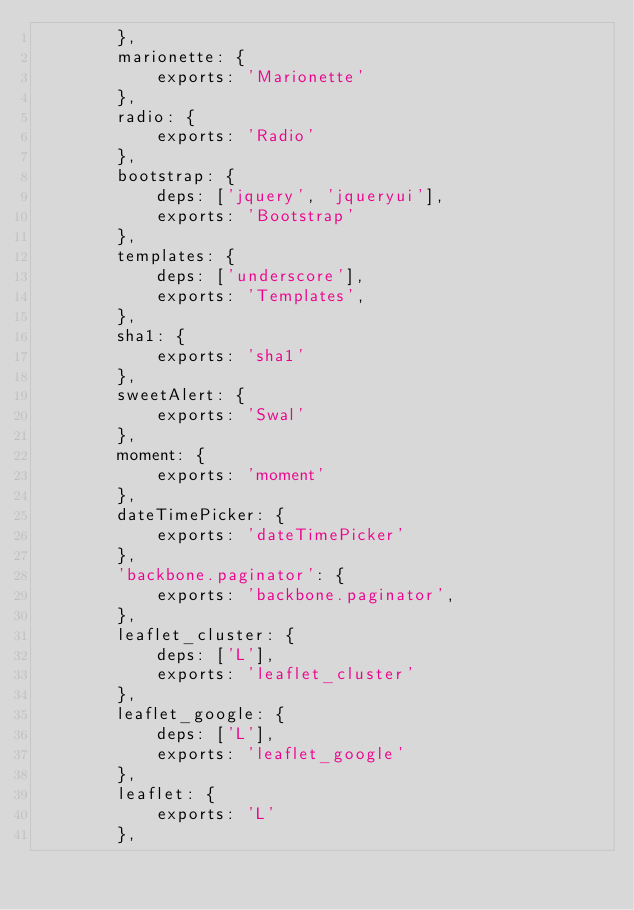Convert code to text. <code><loc_0><loc_0><loc_500><loc_500><_JavaScript_>        },
        marionette: {
            exports: 'Marionette'
        },
        radio: {
            exports: 'Radio'
        },
        bootstrap: {
            deps: ['jquery', 'jqueryui'],
            exports: 'Bootstrap'
        },
        templates: {
            deps: ['underscore'],
            exports: 'Templates',
        },
        sha1: {
            exports: 'sha1'
        },
        sweetAlert: {
            exports: 'Swal'
        },
        moment: {
            exports: 'moment'
        },
        dateTimePicker: {
            exports: 'dateTimePicker'
        },
        'backbone.paginator': {
            exports: 'backbone.paginator',
        },
        leaflet_cluster: {
            deps: ['L'],
            exports: 'leaflet_cluster'
        },
        leaflet_google: {
            deps: ['L'],
            exports: 'leaflet_google'
        },
        leaflet: {
            exports: 'L'
        },</code> 